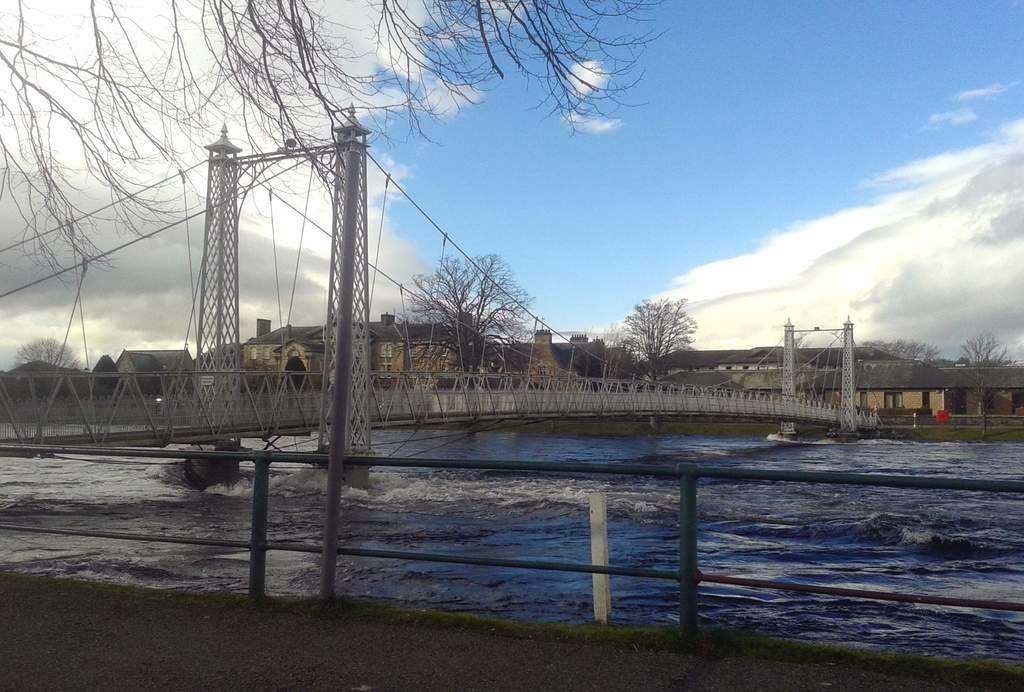In one or two sentences, can you explain what this image depicts? In this image we can see a bridge, water under the bridge, an iron railing and in the background there are few trees, buildings and the sky with clouds. 